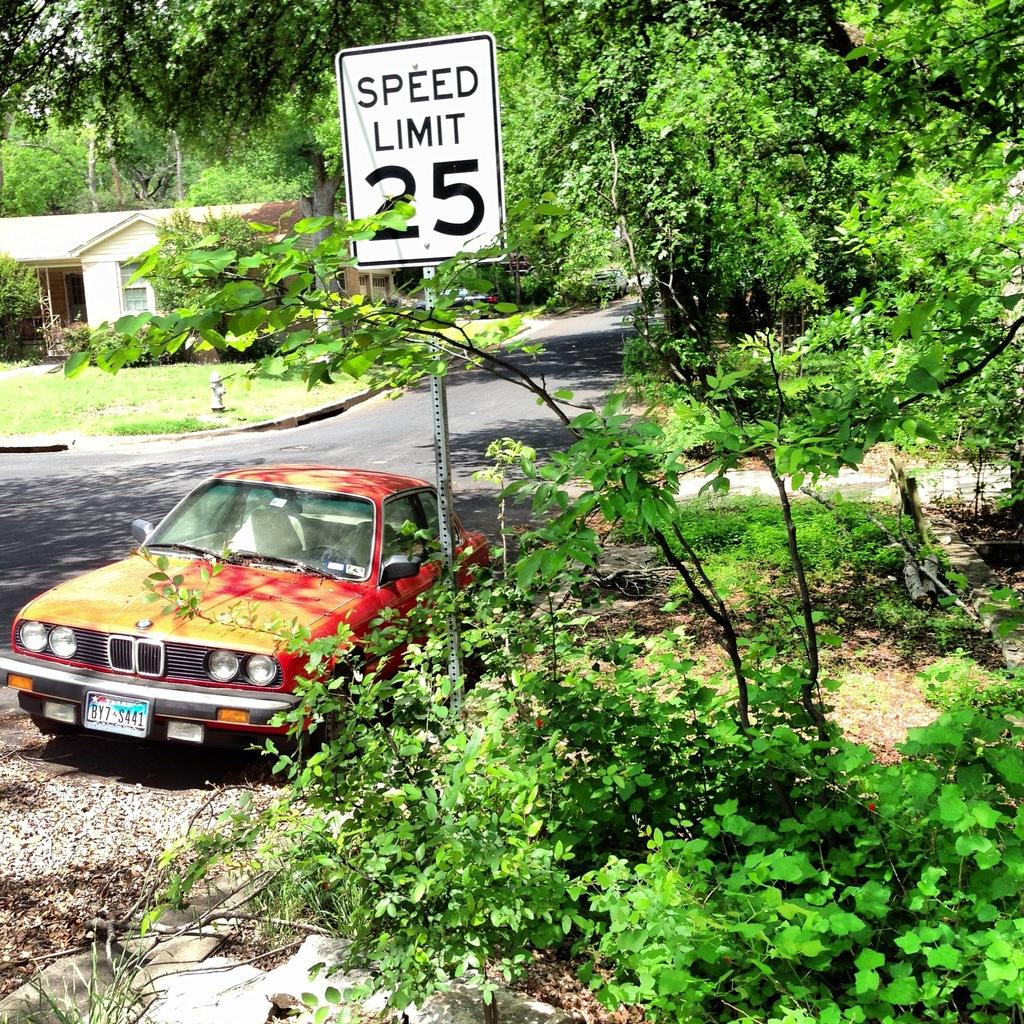What is the main object in the image? There is a board in the image. What type of vegetation can be seen in the image? There are plants and trees in the image. What is the setting of the image? There is a car, a road, grass, and a house in the background, suggesting an outdoor scene. What is the background of the image? There are trees in the background of the image. What type of straw is being used to support the neck of the person in the image? There is no person present in the image, and therefore no straw or neck to support. 